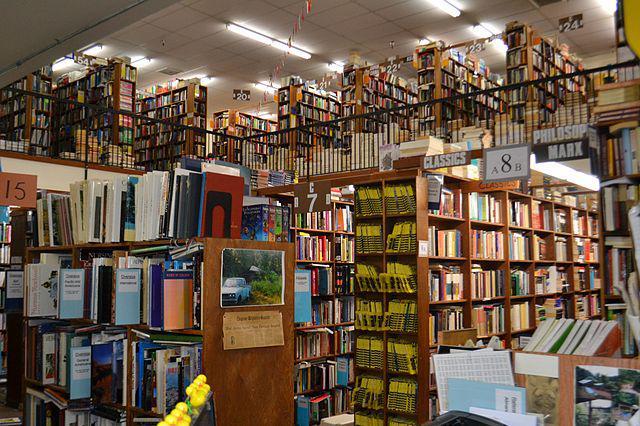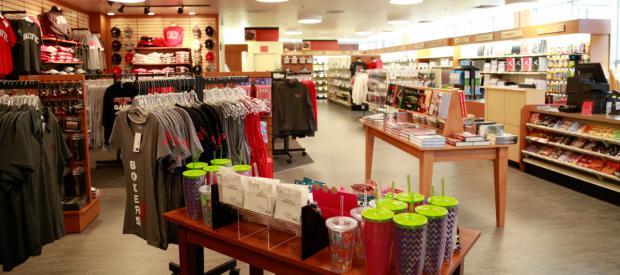The first image is the image on the left, the second image is the image on the right. Analyze the images presented: Is the assertion "One or more customers are shown in a bookstore." valid? Answer yes or no. No. 